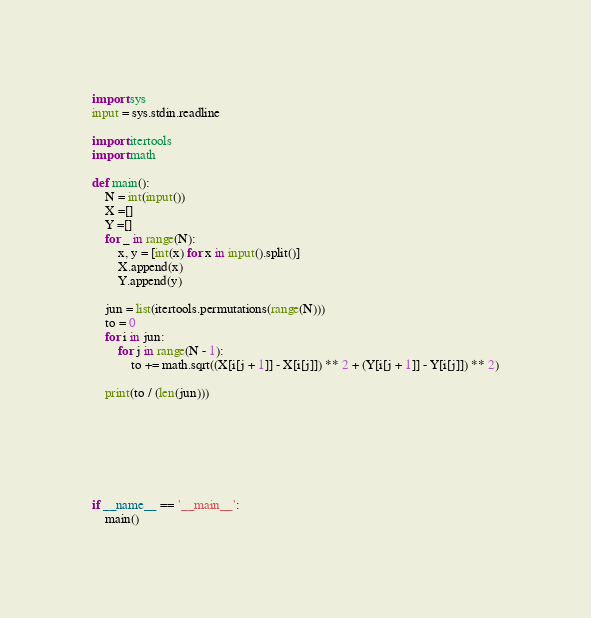Convert code to text. <code><loc_0><loc_0><loc_500><loc_500><_Python_>import sys
input = sys.stdin.readline

import itertools
import math

def main():
    N = int(input())
    X =[]
    Y =[]
    for _ in range(N):
        x, y = [int(x) for x in input().split()]
        X.append(x)
        Y.append(y)

    jun = list(itertools.permutations(range(N)))
    to = 0
    for i in jun:
        for j in range(N - 1):
            to += math.sqrt((X[i[j + 1]] - X[i[j]]) ** 2 + (Y[i[j + 1]] - Y[i[j]]) ** 2)

    print(to / (len(jun)))







if __name__ == '__main__':
    main()

</code> 